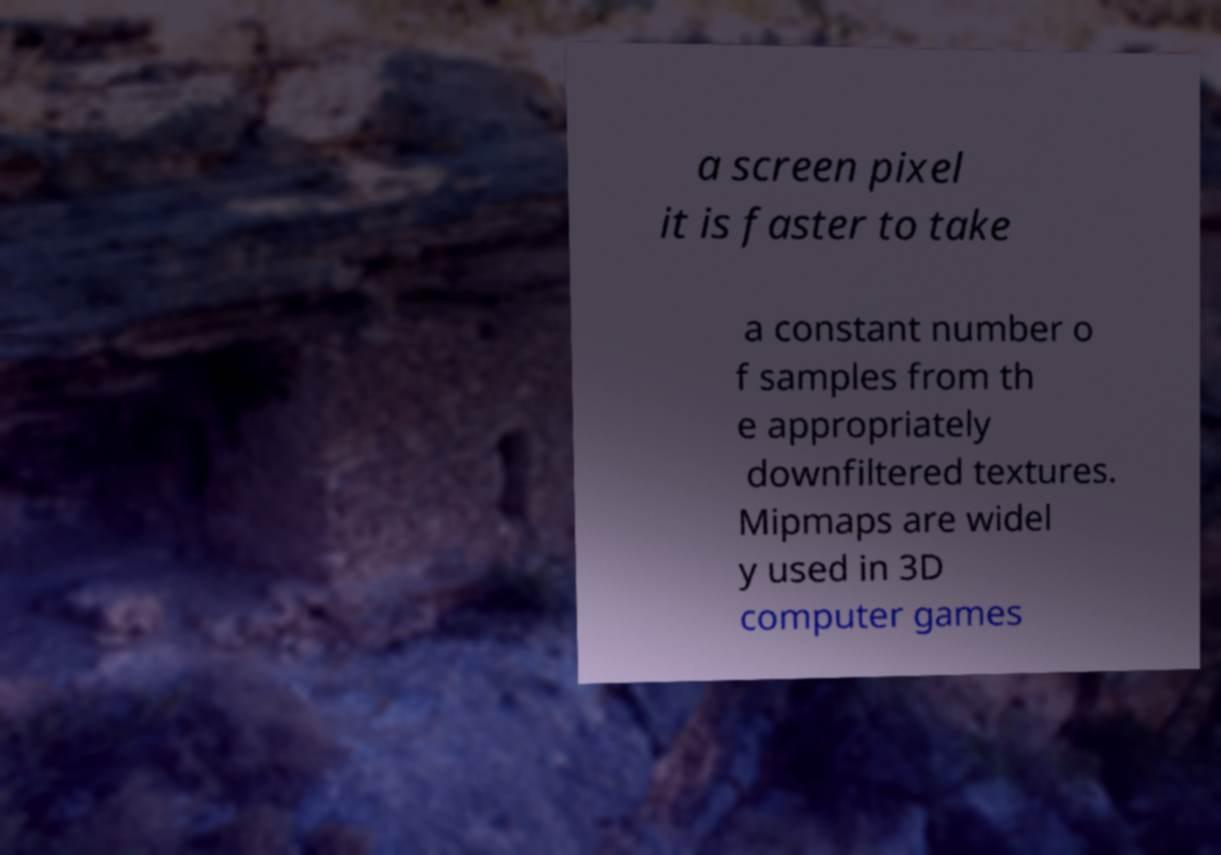What messages or text are displayed in this image? I need them in a readable, typed format. a screen pixel it is faster to take a constant number o f samples from th e appropriately downfiltered textures. Mipmaps are widel y used in 3D computer games 